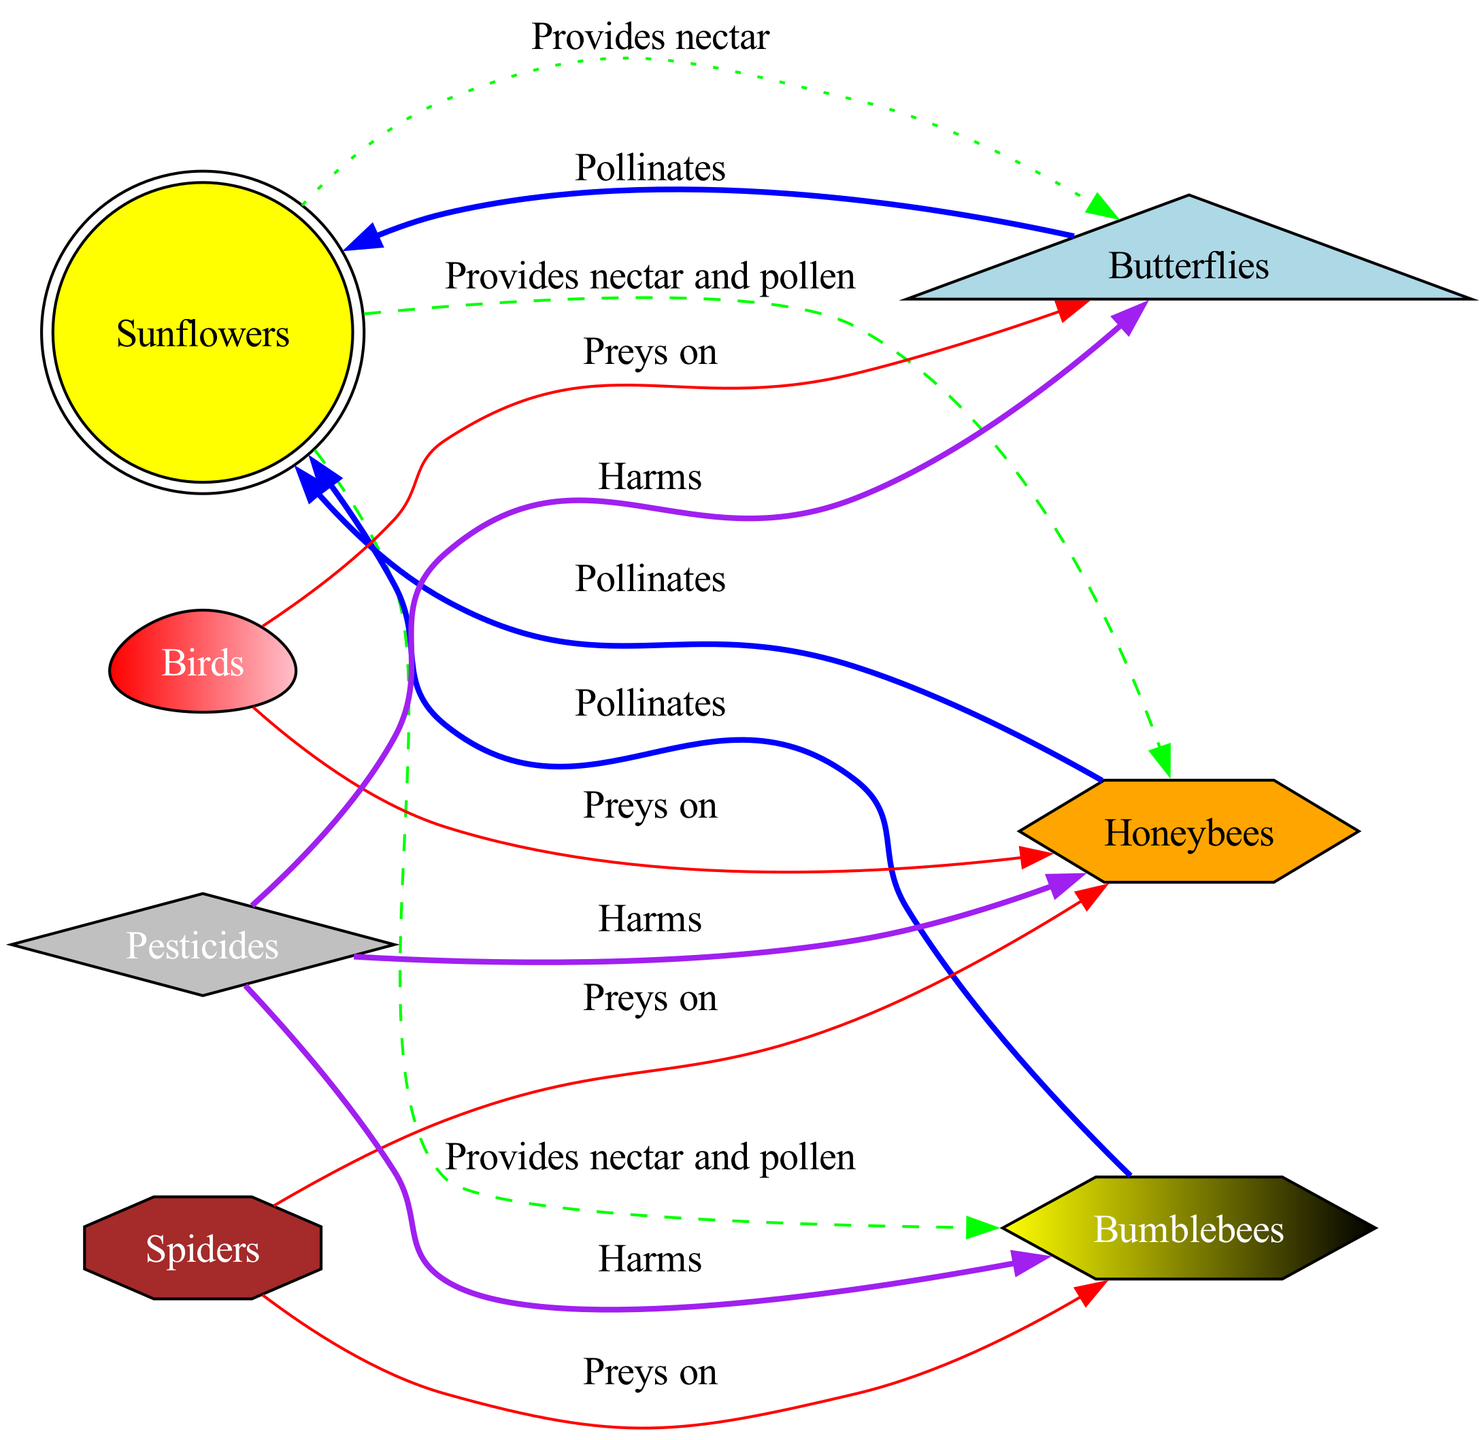What are the three types of pollinators shown in the diagram? The diagram displays three types of pollinators: Honeybees, Bumblebees, and Butterflies. This can be determined by identifying the nodes labeled as pollinators in the diagram.
Answer: Honeybees, Bumblebees, Butterflies How many nodes are there in total? To find the total number of nodes, I count all the unique entities represented in the diagram, which are Sunflowers, Honeybees, Bumblebees, Butterflies, Birds, Spiders, and Pesticides. This sums up to seven nodes.
Answer: 7 What does Sunflowers provide? The diagram indicates that Sunflowers provide nectar and pollen to Honeybees and Bumblebees. The specific relationship is labeled in the connecting edges, using the description "Provides nectar and pollen."
Answer: Nectar and pollen Which organism preys on Bumblebees? In examining the edges, I notice that Birds and Spiders are pointed at Bumblebees with the label "Preys on." This means both organisms interact negatively with Bumblebees by feeding on them.
Answer: Birds, Spiders How many relationships involve Pesticides? By analyzing the edges connected to the Pesticides node, I count three connections: two labeled "Harms" towards Honeybees and Bumblebees, and one towards Butterflies. Therefore, Pesticides are involved in three relationships.
Answer: 3 Which pollinator(s) has/ have only one type of interaction with plants? Looking closely at the interactions, I see that Butterflies are involved with Sunflowers through one type of interaction, labeled "Pollinates," which is distinct from the two interactions Honeybees and Bumblebees have. The others have multiple types of interactions.
Answer: Butterflies What colors signify the harm from Pesticides? The diagram uses the color purple to signify harmful interactions. The edges indicating harm all have this color, clearly denoting the negative impacts of Pesticides on pollinators.
Answer: Purple What is the relationship between birds and honeybees? The edge labeled "Preys on" between Birds and Honeybees indicates a predatory relationship, where Birds feed on Honeybees, showcasing a detrimental interaction within the food web.
Answer: Preys on 